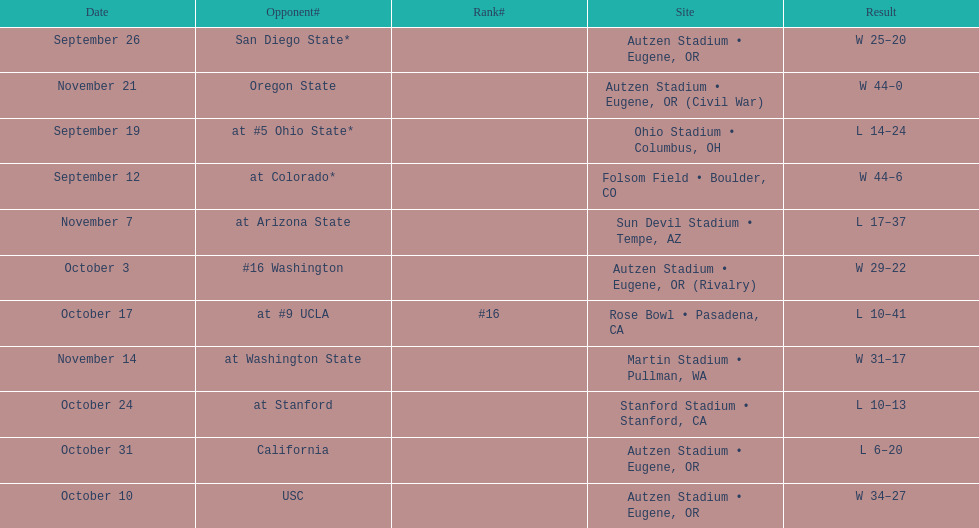Which bowl game did the university of oregon ducks football team play in during the 1987 season? Rose Bowl. 